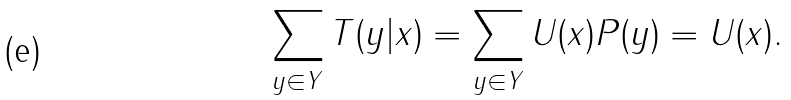<formula> <loc_0><loc_0><loc_500><loc_500>\sum _ { y \in Y } T ( y | x ) = \sum _ { y \in Y } U ( x ) P ( y ) = U ( x ) .</formula> 